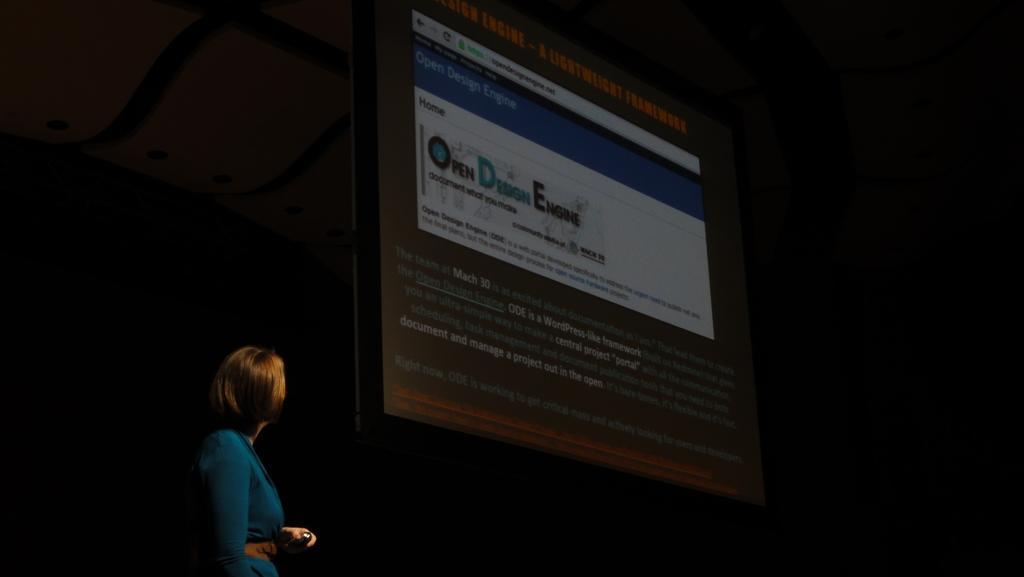In one or two sentences, can you explain what this image depicts? This is the picture of a lady in green dress standing beside the projector screen. 